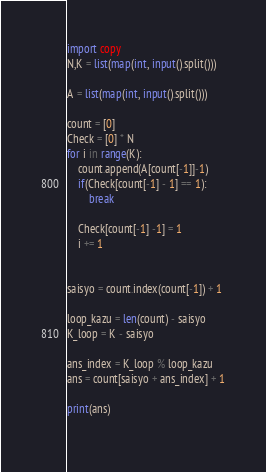<code> <loc_0><loc_0><loc_500><loc_500><_Python_>import copy
N,K = list(map(int, input().split()))
 
A = list(map(int, input().split()))
 
count = [0]
Check = [0] * N
for i in range(K):
    count.append(A[count[-1]]-1)
    if(Check[count[-1] - 1] == 1):
        break
 
    Check[count[-1] -1] = 1
    i += 1
 
 
saisyo = count.index(count[-1]) + 1
 
loop_kazu = len(count) - saisyo
K_loop = K - saisyo
 
ans_index = K_loop % loop_kazu
ans = count[saisyo + ans_index] + 1
 
print(ans)
 </code> 